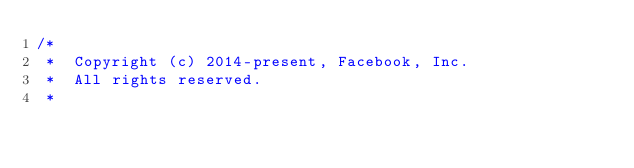Convert code to text. <code><loc_0><loc_0><loc_500><loc_500><_ObjectiveC_>/*
 *  Copyright (c) 2014-present, Facebook, Inc.
 *  All rights reserved.
 *</code> 